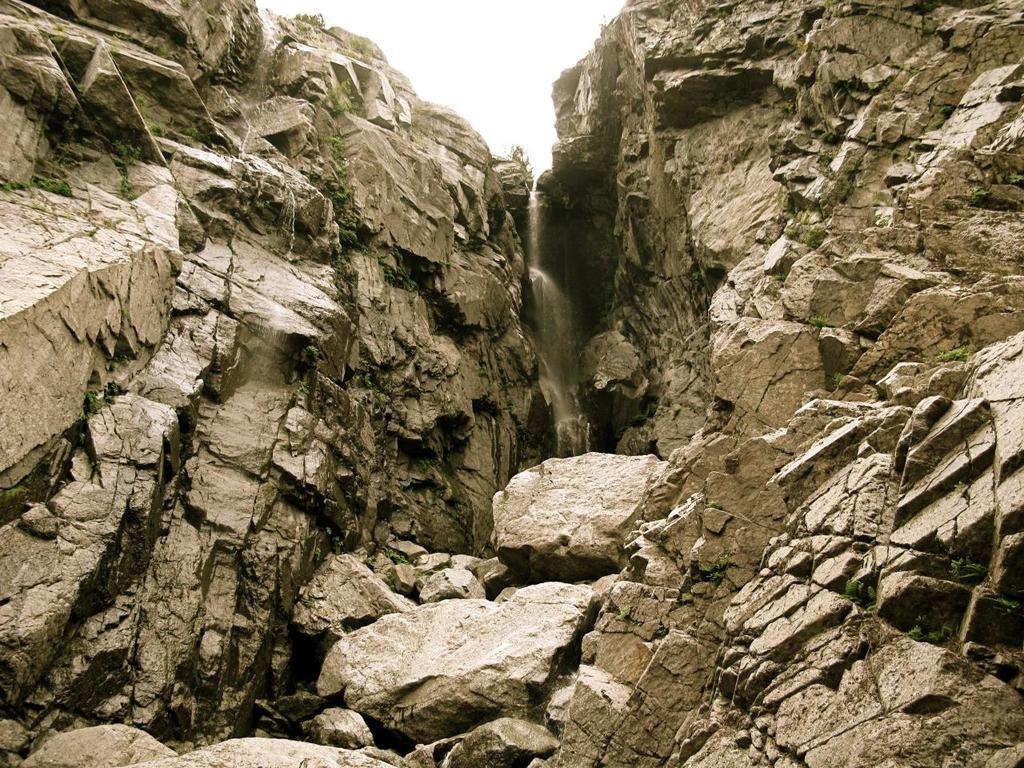What natural feature is the main subject of the image? There is a waterfall in the image. How is the waterfall positioned between the two mountains? The waterfall is situated between two mountains. What part of the sky is visible in the image? The sky is visible above the waterfall. What unit of measurement is used to determine the height of the brother holding the rifle in the image? There is no brother holding a rifle present in the image; it features a waterfall situated between two mountains. 